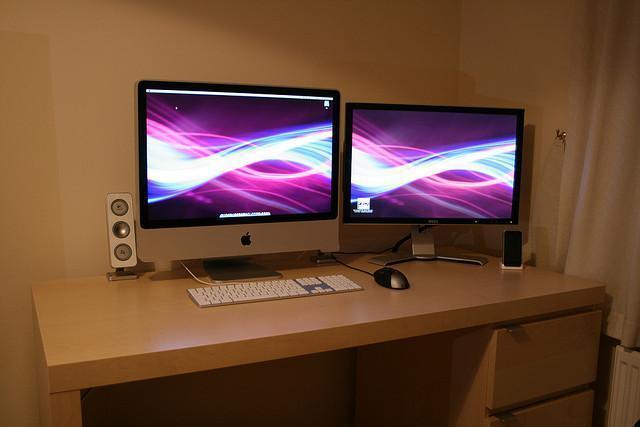How many screens are there?
Give a very brief answer. 2. How many tvs are in the picture?
Give a very brief answer. 2. 